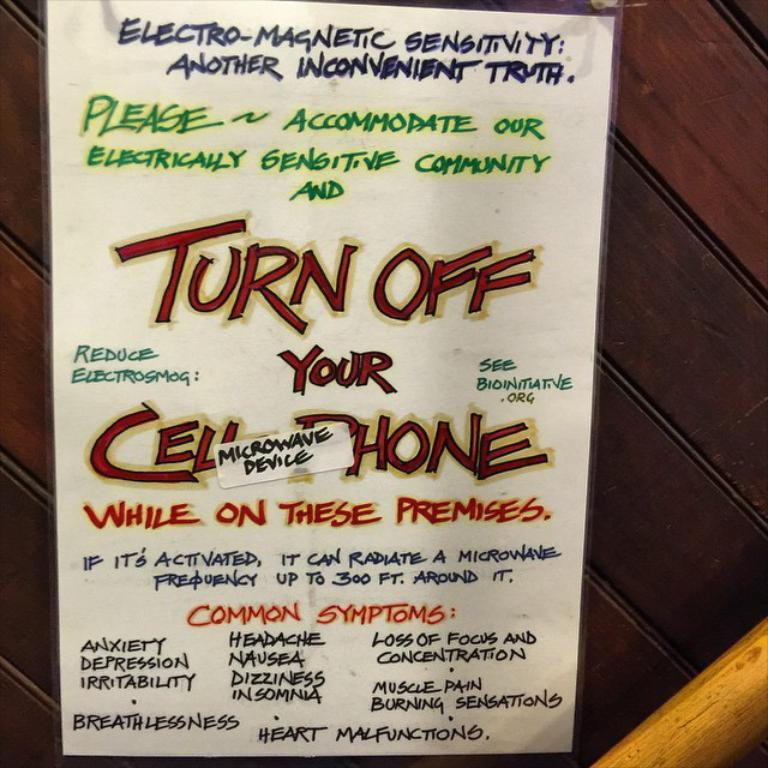<image>
Write a terse but informative summary of the picture. A sign asks visitors to turn their cellphones off while on the premises and lists reasons why. 